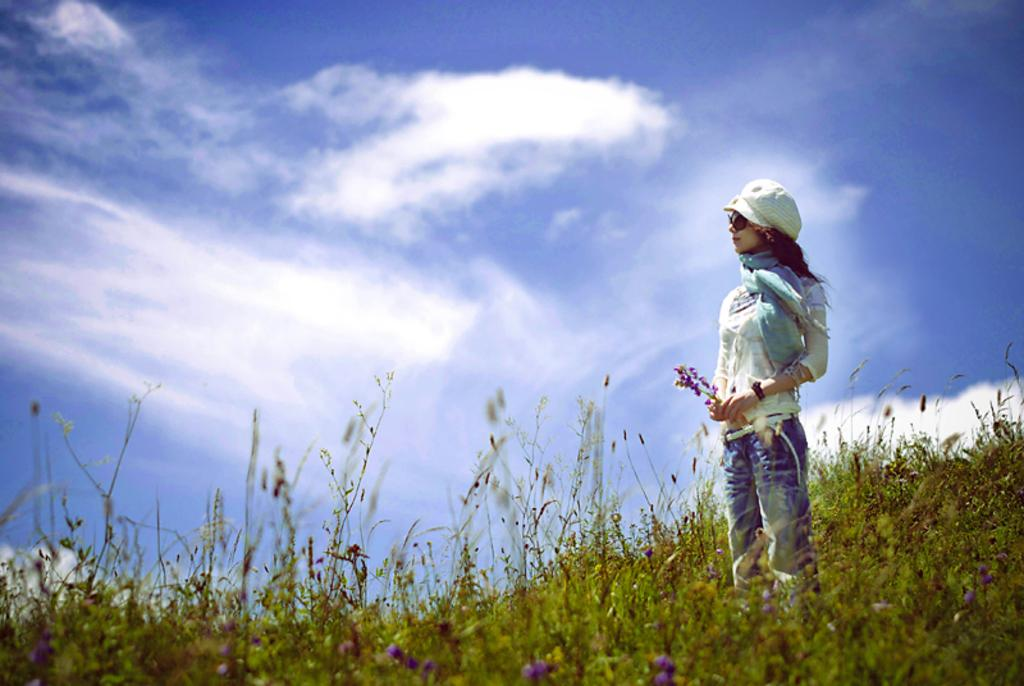Who is present in the image? There is a woman in the image. What is the woman doing in the image? The woman is standing in the image. What is the woman holding in the image? The woman is holding a flower in the image. What type of vegetation can be seen in the image? There are flowers on plants in the image. What is visible at the top of the image? The sky is visible at the top of the image. What can be observed about the sky in the image? There are clouds in the sky in the image. What type of gate can be seen in the image? There is no gate present in the image. What does the flower smell like in the image? The image does not provide information about the scent of the flower. 